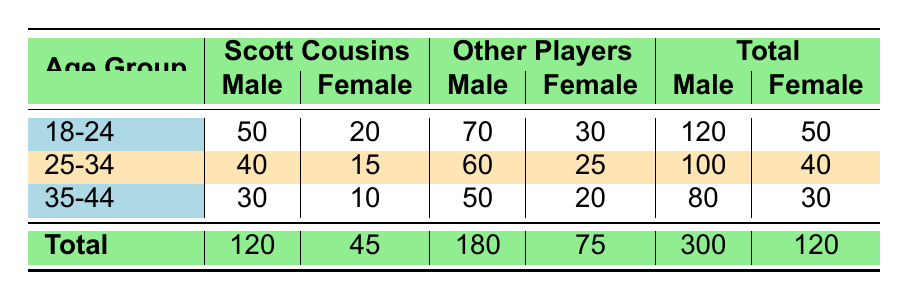What is the total number of male MiniFootball fans aged 25-34? In the table, the row for the age group 25-34 shows that there are 100 male fans.
Answer: 100 How many female fans have Scott Cousins as their favorite player in the 18-24 age group? The table indicates that there are 20 female fans aged 18-24 who like Scott Cousins.
Answer: 20 What is the total number of fans who prefer Scott Cousins across all age groups? We sum the male and female fans who like Scott Cousins across all age groups: 50 + 20 (18-24) + 40 + 15 (25-34) + 30 + 10 (35-44) = 165.
Answer: 165 Do more male fans aged 35-44 prefer Scott Cousins than female fans of the same age group? Male fans aged 35-44 who prefer Scott Cousins number 30, while female fans in the same age group number 10. Since 30 > 10, the statement is true.
Answer: Yes What is the combined total of fans who prefer other players in the 25-34 age group? For male fans aged 25-34, the total for other players is 60 (Daniel Silver 30, Michael Grey 20, Chris Brown 10). For female fans, it is 25 (Hannah Gold 10, Ava Purple 10, Zoe Orange 5). Adding these together gives 60 + 25 = 85.
Answer: 85 Is the total number of female fans for all age groups less than 50? The total number of female fans across all age groups is 50 (18-24) + 40 (25-34) + 30 (35-44) = 120. Since 120 is greater than 50, the statement is false.
Answer: No What is the percentage of male fans aged 18-24 who prefer Scott Cousins? There are 50 fans aged 18-24 who prefer Scott Cousins and a total of 120 male fans in that age group. The percentage is (50 / 120) * 100 = 41.67%.
Answer: 41.67% How many more male fans than female fans prefer other players in the age group 35-44? For male fans in the 35-44 age group, the total for other players is 50. For female fans, it is 20; thus, we calculate 50 - 20 = 30.
Answer: 30 What is the average number of fans in each gender group across the age groups? We calculate the average by taking the total number of male fans (120 + 100 + 80 = 300) and dividing by 3, yielding an average of 100. The same calculation for females yields an average of 40.
Answer: 100 for males, 40 for females 